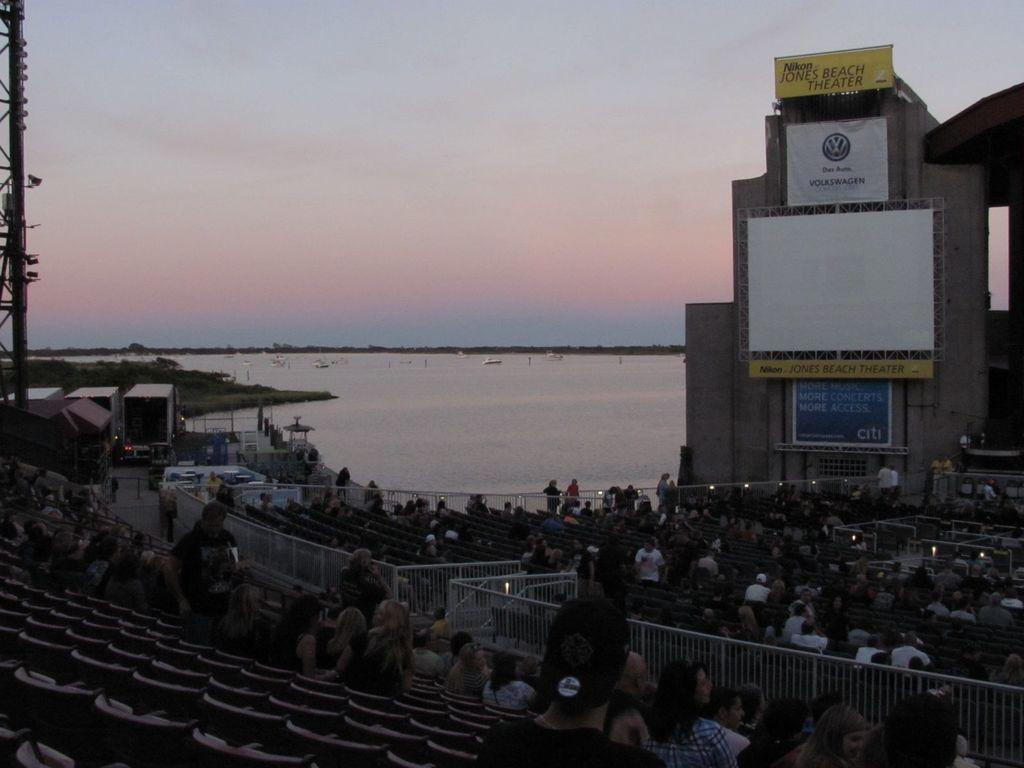What type of structure is present in the image? There is a building in the image. What can be seen on the boards in the image? There are boards with text in the image. What type of furniture is visible in the image? There are chairs in the image. What type of barrier is present in the image? There is a fence in the image. Who or what is present in the image? There are people in the image. What type of vegetation is visible in the image? There is grass in the image. What type of natural feature is visible in the image? There is water visible in the image. What type of transportation is present in the image? There are boats in the image. What type of vertical structure is present in the image? There is a pole in the image. What type of illumination is present in the image? There are lights in the image. What can be seen in the background of the image? The sky is visible in the background of the image. Where is the kettle located in the image? There is no kettle present in the image. How many brothers are visible in the image? There is no mention of brothers in the image, and no indication of their presence. Who is taking the picture in the image? There is no camera or person taking a picture visible in the image. 